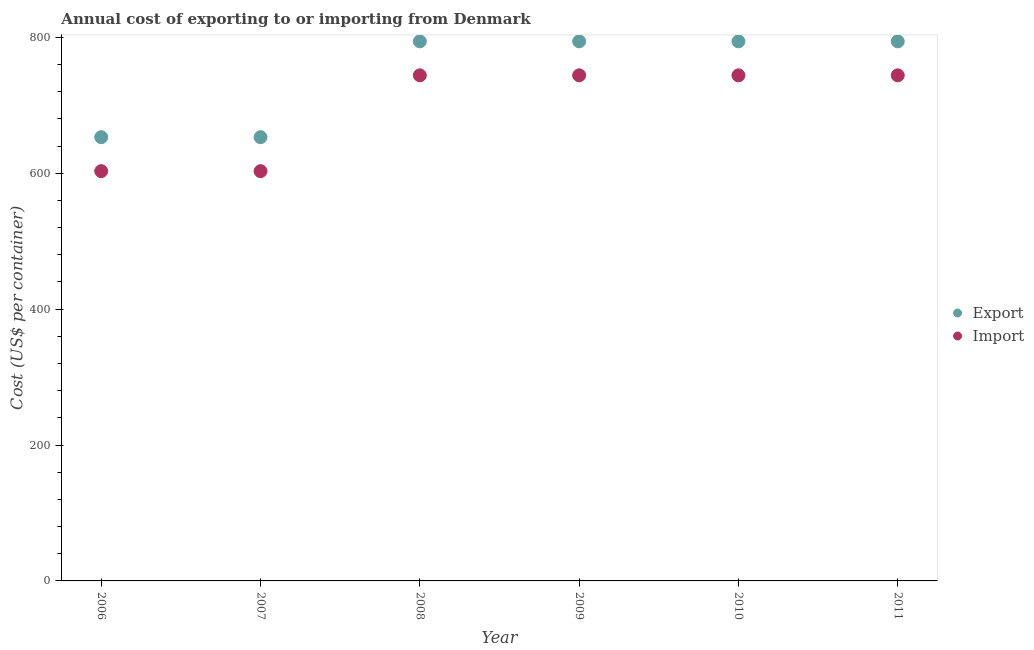What is the export cost in 2007?
Give a very brief answer. 653. Across all years, what is the maximum import cost?
Ensure brevity in your answer.  744. Across all years, what is the minimum import cost?
Your answer should be very brief. 603. In which year was the import cost maximum?
Your answer should be very brief. 2008. In which year was the import cost minimum?
Keep it short and to the point. 2006. What is the total import cost in the graph?
Provide a succinct answer. 4182. What is the difference between the export cost in 2011 and the import cost in 2007?
Your answer should be compact. 191. What is the average import cost per year?
Provide a succinct answer. 697. In the year 2007, what is the difference between the import cost and export cost?
Your answer should be compact. -50. In how many years, is the export cost greater than 280 US$?
Keep it short and to the point. 6. What is the difference between the highest and the second highest import cost?
Your answer should be very brief. 0. What is the difference between the highest and the lowest import cost?
Give a very brief answer. 141. In how many years, is the export cost greater than the average export cost taken over all years?
Ensure brevity in your answer.  4. Is the sum of the export cost in 2007 and 2009 greater than the maximum import cost across all years?
Ensure brevity in your answer.  Yes. Does the import cost monotonically increase over the years?
Your answer should be very brief. No. How many dotlines are there?
Make the answer very short. 2. How many years are there in the graph?
Your response must be concise. 6. Are the values on the major ticks of Y-axis written in scientific E-notation?
Offer a very short reply. No. Does the graph contain grids?
Offer a very short reply. No. Where does the legend appear in the graph?
Ensure brevity in your answer.  Center right. How are the legend labels stacked?
Make the answer very short. Vertical. What is the title of the graph?
Provide a succinct answer. Annual cost of exporting to or importing from Denmark. Does "Private consumption" appear as one of the legend labels in the graph?
Provide a succinct answer. No. What is the label or title of the Y-axis?
Provide a short and direct response. Cost (US$ per container). What is the Cost (US$ per container) in Export in 2006?
Your response must be concise. 653. What is the Cost (US$ per container) in Import in 2006?
Your response must be concise. 603. What is the Cost (US$ per container) in Export in 2007?
Your answer should be compact. 653. What is the Cost (US$ per container) in Import in 2007?
Offer a terse response. 603. What is the Cost (US$ per container) in Export in 2008?
Provide a succinct answer. 794. What is the Cost (US$ per container) of Import in 2008?
Provide a succinct answer. 744. What is the Cost (US$ per container) in Export in 2009?
Your answer should be very brief. 794. What is the Cost (US$ per container) of Import in 2009?
Make the answer very short. 744. What is the Cost (US$ per container) of Export in 2010?
Your answer should be very brief. 794. What is the Cost (US$ per container) in Import in 2010?
Provide a succinct answer. 744. What is the Cost (US$ per container) in Export in 2011?
Provide a succinct answer. 794. What is the Cost (US$ per container) of Import in 2011?
Make the answer very short. 744. Across all years, what is the maximum Cost (US$ per container) of Export?
Your answer should be compact. 794. Across all years, what is the maximum Cost (US$ per container) of Import?
Your answer should be compact. 744. Across all years, what is the minimum Cost (US$ per container) in Export?
Make the answer very short. 653. Across all years, what is the minimum Cost (US$ per container) of Import?
Offer a terse response. 603. What is the total Cost (US$ per container) of Export in the graph?
Provide a short and direct response. 4482. What is the total Cost (US$ per container) in Import in the graph?
Provide a succinct answer. 4182. What is the difference between the Cost (US$ per container) of Export in 2006 and that in 2007?
Provide a succinct answer. 0. What is the difference between the Cost (US$ per container) in Export in 2006 and that in 2008?
Make the answer very short. -141. What is the difference between the Cost (US$ per container) of Import in 2006 and that in 2008?
Give a very brief answer. -141. What is the difference between the Cost (US$ per container) of Export in 2006 and that in 2009?
Ensure brevity in your answer.  -141. What is the difference between the Cost (US$ per container) in Import in 2006 and that in 2009?
Provide a succinct answer. -141. What is the difference between the Cost (US$ per container) in Export in 2006 and that in 2010?
Your answer should be compact. -141. What is the difference between the Cost (US$ per container) in Import in 2006 and that in 2010?
Provide a succinct answer. -141. What is the difference between the Cost (US$ per container) in Export in 2006 and that in 2011?
Keep it short and to the point. -141. What is the difference between the Cost (US$ per container) of Import in 2006 and that in 2011?
Give a very brief answer. -141. What is the difference between the Cost (US$ per container) in Export in 2007 and that in 2008?
Your response must be concise. -141. What is the difference between the Cost (US$ per container) of Import in 2007 and that in 2008?
Offer a terse response. -141. What is the difference between the Cost (US$ per container) of Export in 2007 and that in 2009?
Your answer should be very brief. -141. What is the difference between the Cost (US$ per container) in Import in 2007 and that in 2009?
Your answer should be very brief. -141. What is the difference between the Cost (US$ per container) of Export in 2007 and that in 2010?
Keep it short and to the point. -141. What is the difference between the Cost (US$ per container) in Import in 2007 and that in 2010?
Provide a short and direct response. -141. What is the difference between the Cost (US$ per container) of Export in 2007 and that in 2011?
Keep it short and to the point. -141. What is the difference between the Cost (US$ per container) in Import in 2007 and that in 2011?
Make the answer very short. -141. What is the difference between the Cost (US$ per container) of Export in 2008 and that in 2009?
Give a very brief answer. 0. What is the difference between the Cost (US$ per container) of Import in 2008 and that in 2009?
Offer a very short reply. 0. What is the difference between the Cost (US$ per container) in Export in 2008 and that in 2010?
Your response must be concise. 0. What is the difference between the Cost (US$ per container) in Export in 2008 and that in 2011?
Provide a short and direct response. 0. What is the difference between the Cost (US$ per container) of Import in 2008 and that in 2011?
Keep it short and to the point. 0. What is the difference between the Cost (US$ per container) of Export in 2009 and that in 2010?
Offer a terse response. 0. What is the difference between the Cost (US$ per container) in Import in 2009 and that in 2010?
Offer a terse response. 0. What is the difference between the Cost (US$ per container) of Import in 2009 and that in 2011?
Keep it short and to the point. 0. What is the difference between the Cost (US$ per container) of Export in 2006 and the Cost (US$ per container) of Import in 2007?
Provide a succinct answer. 50. What is the difference between the Cost (US$ per container) of Export in 2006 and the Cost (US$ per container) of Import in 2008?
Provide a succinct answer. -91. What is the difference between the Cost (US$ per container) in Export in 2006 and the Cost (US$ per container) in Import in 2009?
Keep it short and to the point. -91. What is the difference between the Cost (US$ per container) in Export in 2006 and the Cost (US$ per container) in Import in 2010?
Make the answer very short. -91. What is the difference between the Cost (US$ per container) of Export in 2006 and the Cost (US$ per container) of Import in 2011?
Your response must be concise. -91. What is the difference between the Cost (US$ per container) in Export in 2007 and the Cost (US$ per container) in Import in 2008?
Provide a succinct answer. -91. What is the difference between the Cost (US$ per container) of Export in 2007 and the Cost (US$ per container) of Import in 2009?
Your answer should be compact. -91. What is the difference between the Cost (US$ per container) of Export in 2007 and the Cost (US$ per container) of Import in 2010?
Keep it short and to the point. -91. What is the difference between the Cost (US$ per container) of Export in 2007 and the Cost (US$ per container) of Import in 2011?
Make the answer very short. -91. What is the difference between the Cost (US$ per container) of Export in 2008 and the Cost (US$ per container) of Import in 2009?
Offer a terse response. 50. What is the average Cost (US$ per container) in Export per year?
Ensure brevity in your answer.  747. What is the average Cost (US$ per container) in Import per year?
Your answer should be very brief. 697. In the year 2006, what is the difference between the Cost (US$ per container) in Export and Cost (US$ per container) in Import?
Your answer should be compact. 50. In the year 2007, what is the difference between the Cost (US$ per container) of Export and Cost (US$ per container) of Import?
Make the answer very short. 50. In the year 2008, what is the difference between the Cost (US$ per container) of Export and Cost (US$ per container) of Import?
Offer a very short reply. 50. In the year 2009, what is the difference between the Cost (US$ per container) in Export and Cost (US$ per container) in Import?
Give a very brief answer. 50. In the year 2011, what is the difference between the Cost (US$ per container) of Export and Cost (US$ per container) of Import?
Offer a very short reply. 50. What is the ratio of the Cost (US$ per container) of Import in 2006 to that in 2007?
Make the answer very short. 1. What is the ratio of the Cost (US$ per container) in Export in 2006 to that in 2008?
Offer a very short reply. 0.82. What is the ratio of the Cost (US$ per container) in Import in 2006 to that in 2008?
Make the answer very short. 0.81. What is the ratio of the Cost (US$ per container) of Export in 2006 to that in 2009?
Give a very brief answer. 0.82. What is the ratio of the Cost (US$ per container) of Import in 2006 to that in 2009?
Your answer should be compact. 0.81. What is the ratio of the Cost (US$ per container) in Export in 2006 to that in 2010?
Give a very brief answer. 0.82. What is the ratio of the Cost (US$ per container) of Import in 2006 to that in 2010?
Offer a very short reply. 0.81. What is the ratio of the Cost (US$ per container) of Export in 2006 to that in 2011?
Provide a short and direct response. 0.82. What is the ratio of the Cost (US$ per container) of Import in 2006 to that in 2011?
Ensure brevity in your answer.  0.81. What is the ratio of the Cost (US$ per container) of Export in 2007 to that in 2008?
Make the answer very short. 0.82. What is the ratio of the Cost (US$ per container) in Import in 2007 to that in 2008?
Offer a terse response. 0.81. What is the ratio of the Cost (US$ per container) of Export in 2007 to that in 2009?
Offer a terse response. 0.82. What is the ratio of the Cost (US$ per container) in Import in 2007 to that in 2009?
Your answer should be very brief. 0.81. What is the ratio of the Cost (US$ per container) in Export in 2007 to that in 2010?
Provide a short and direct response. 0.82. What is the ratio of the Cost (US$ per container) in Import in 2007 to that in 2010?
Ensure brevity in your answer.  0.81. What is the ratio of the Cost (US$ per container) in Export in 2007 to that in 2011?
Provide a short and direct response. 0.82. What is the ratio of the Cost (US$ per container) of Import in 2007 to that in 2011?
Your response must be concise. 0.81. What is the ratio of the Cost (US$ per container) in Export in 2008 to that in 2011?
Provide a short and direct response. 1. What is the ratio of the Cost (US$ per container) in Import in 2008 to that in 2011?
Give a very brief answer. 1. What is the ratio of the Cost (US$ per container) in Export in 2009 to that in 2010?
Your answer should be very brief. 1. What is the ratio of the Cost (US$ per container) in Export in 2009 to that in 2011?
Provide a short and direct response. 1. What is the ratio of the Cost (US$ per container) in Import in 2009 to that in 2011?
Your response must be concise. 1. What is the difference between the highest and the second highest Cost (US$ per container) of Export?
Your answer should be very brief. 0. What is the difference between the highest and the second highest Cost (US$ per container) in Import?
Offer a very short reply. 0. What is the difference between the highest and the lowest Cost (US$ per container) of Export?
Provide a short and direct response. 141. What is the difference between the highest and the lowest Cost (US$ per container) in Import?
Your answer should be very brief. 141. 